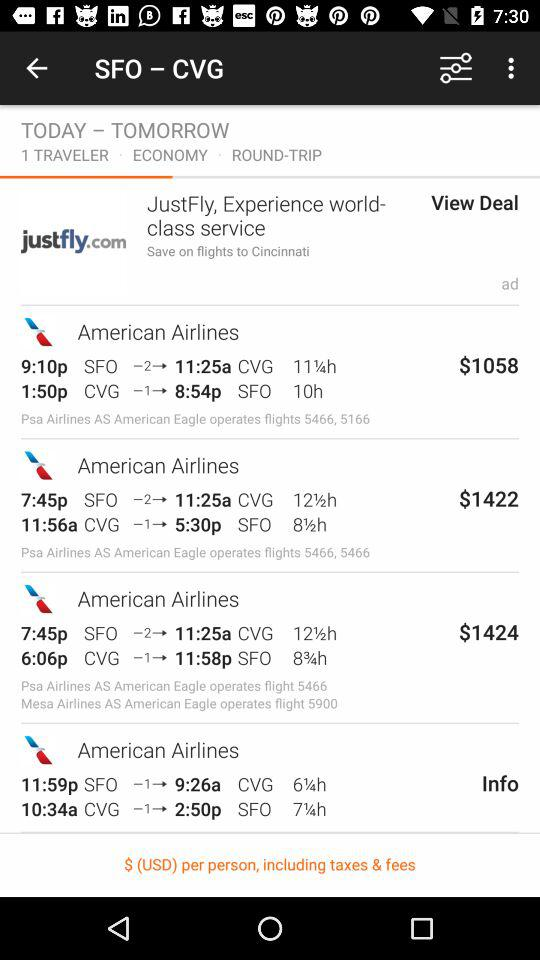What is the cost of the American Airlines flight, which is at 9:10? The cost is $1058. 